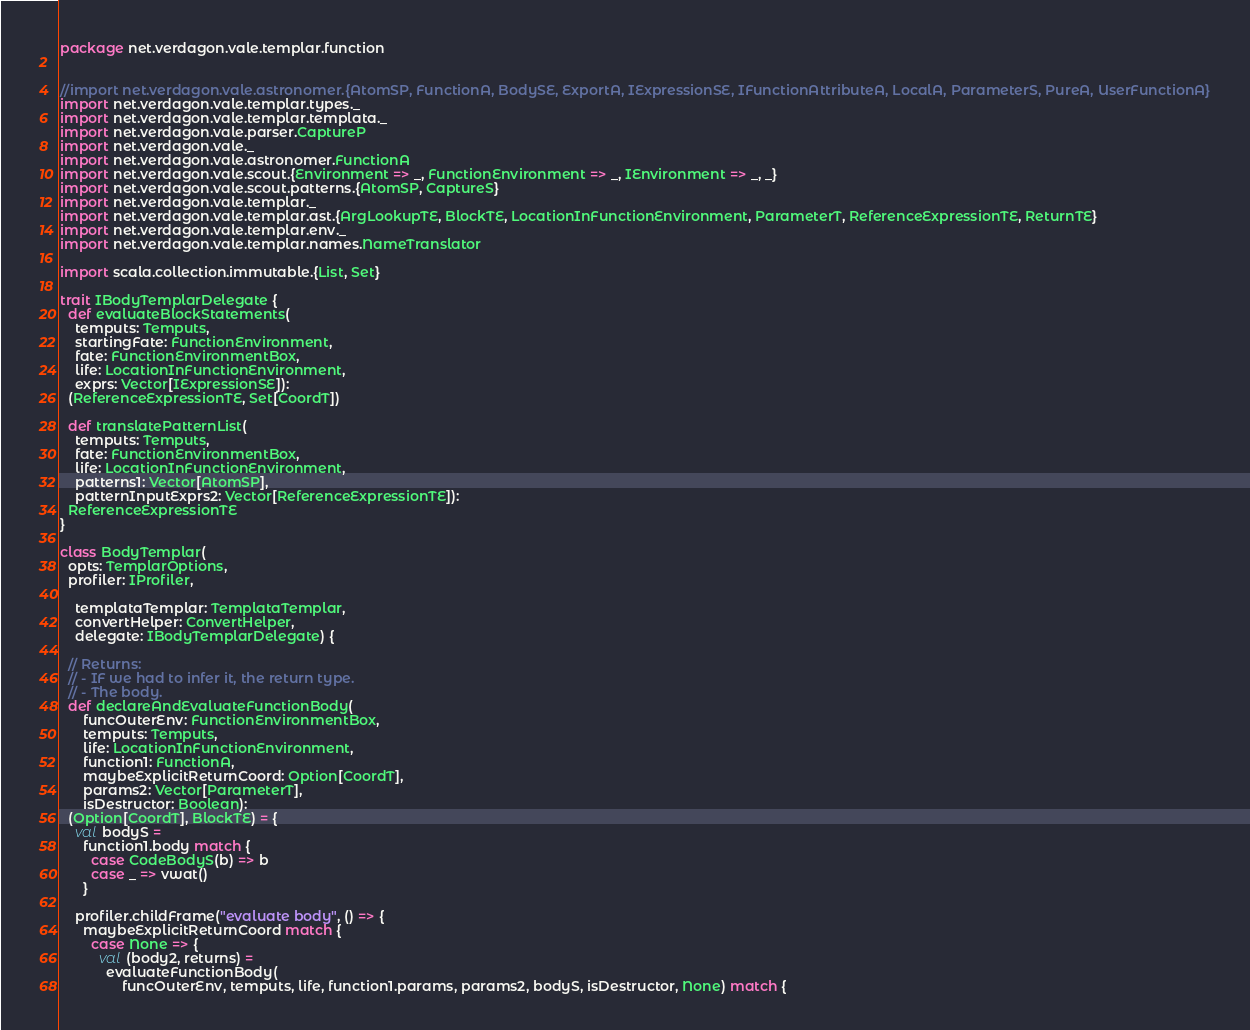Convert code to text. <code><loc_0><loc_0><loc_500><loc_500><_Scala_>package net.verdagon.vale.templar.function


//import net.verdagon.vale.astronomer.{AtomSP, FunctionA, BodySE, ExportA, IExpressionSE, IFunctionAttributeA, LocalA, ParameterS, PureA, UserFunctionA}
import net.verdagon.vale.templar.types._
import net.verdagon.vale.templar.templata._
import net.verdagon.vale.parser.CaptureP
import net.verdagon.vale._
import net.verdagon.vale.astronomer.FunctionA
import net.verdagon.vale.scout.{Environment => _, FunctionEnvironment => _, IEnvironment => _, _}
import net.verdagon.vale.scout.patterns.{AtomSP, CaptureS}
import net.verdagon.vale.templar._
import net.verdagon.vale.templar.ast.{ArgLookupTE, BlockTE, LocationInFunctionEnvironment, ParameterT, ReferenceExpressionTE, ReturnTE}
import net.verdagon.vale.templar.env._
import net.verdagon.vale.templar.names.NameTranslator

import scala.collection.immutable.{List, Set}

trait IBodyTemplarDelegate {
  def evaluateBlockStatements(
    temputs: Temputs,
    startingFate: FunctionEnvironment,
    fate: FunctionEnvironmentBox,
    life: LocationInFunctionEnvironment,
    exprs: Vector[IExpressionSE]):
  (ReferenceExpressionTE, Set[CoordT])

  def translatePatternList(
    temputs: Temputs,
    fate: FunctionEnvironmentBox,
    life: LocationInFunctionEnvironment,
    patterns1: Vector[AtomSP],
    patternInputExprs2: Vector[ReferenceExpressionTE]):
  ReferenceExpressionTE
}

class BodyTemplar(
  opts: TemplarOptions,
  profiler: IProfiler,

    templataTemplar: TemplataTemplar,
    convertHelper: ConvertHelper,
    delegate: IBodyTemplarDelegate) {

  // Returns:
  // - IF we had to infer it, the return type.
  // - The body.
  def declareAndEvaluateFunctionBody(
      funcOuterEnv: FunctionEnvironmentBox,
      temputs: Temputs,
      life: LocationInFunctionEnvironment,
      function1: FunctionA,
      maybeExplicitReturnCoord: Option[CoordT],
      params2: Vector[ParameterT],
      isDestructor: Boolean):
  (Option[CoordT], BlockTE) = {
    val bodyS =
      function1.body match {
        case CodeBodyS(b) => b
        case _ => vwat()
      }

    profiler.childFrame("evaluate body", () => {
      maybeExplicitReturnCoord match {
        case None => {
          val (body2, returns) =
            evaluateFunctionBody(
                funcOuterEnv, temputs, life, function1.params, params2, bodyS, isDestructor, None) match {</code> 